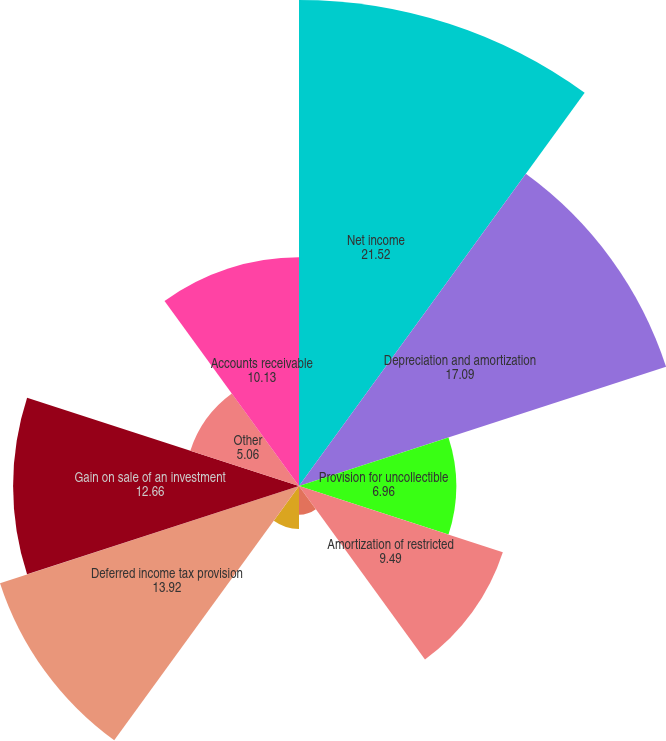Convert chart. <chart><loc_0><loc_0><loc_500><loc_500><pie_chart><fcel>Net income<fcel>Depreciation and amortization<fcel>Provision for uncollectible<fcel>Amortization of restricted<fcel>Net amortization of bond<fcel>Non-cash (gain) loss related<fcel>Deferred income tax provision<fcel>Gain on sale of an investment<fcel>Other<fcel>Accounts receivable<nl><fcel>21.52%<fcel>17.09%<fcel>6.96%<fcel>9.49%<fcel>1.27%<fcel>1.9%<fcel>13.92%<fcel>12.66%<fcel>5.06%<fcel>10.13%<nl></chart> 